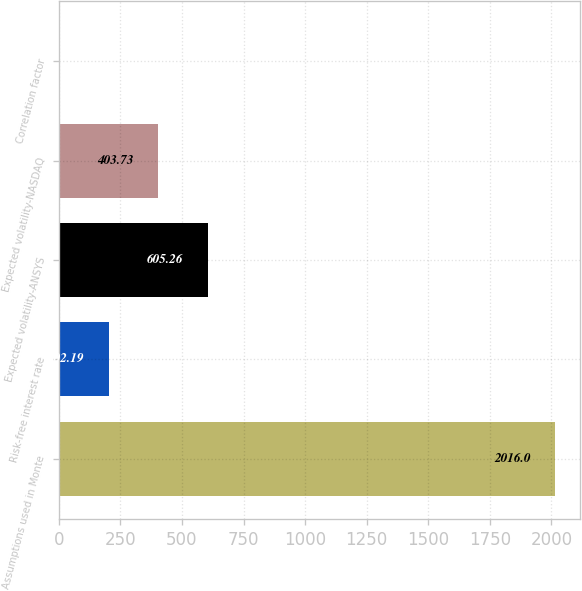Convert chart to OTSL. <chart><loc_0><loc_0><loc_500><loc_500><bar_chart><fcel>Assumptions used in Monte<fcel>Risk-free interest rate<fcel>Expected volatility-ANSYS<fcel>Expected volatility-NASDAQ<fcel>Correlation factor<nl><fcel>2016<fcel>202.19<fcel>605.26<fcel>403.73<fcel>0.65<nl></chart> 